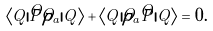<formula> <loc_0><loc_0><loc_500><loc_500>\langle Q | \hat { P } \hat { \rho } _ { a } | Q \rangle + \langle Q | \hat { \rho } _ { a } \hat { P } | Q \rangle = 0 .</formula> 